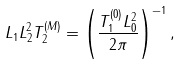Convert formula to latex. <formula><loc_0><loc_0><loc_500><loc_500>L _ { 1 } L _ { 2 } ^ { 2 } T _ { 2 } ^ { ( M ) } = \left ( { \frac { T _ { 1 } ^ { ( 0 ) } L _ { 0 } ^ { 2 } } { 2 \pi } } \right ) ^ { - 1 } ,</formula> 